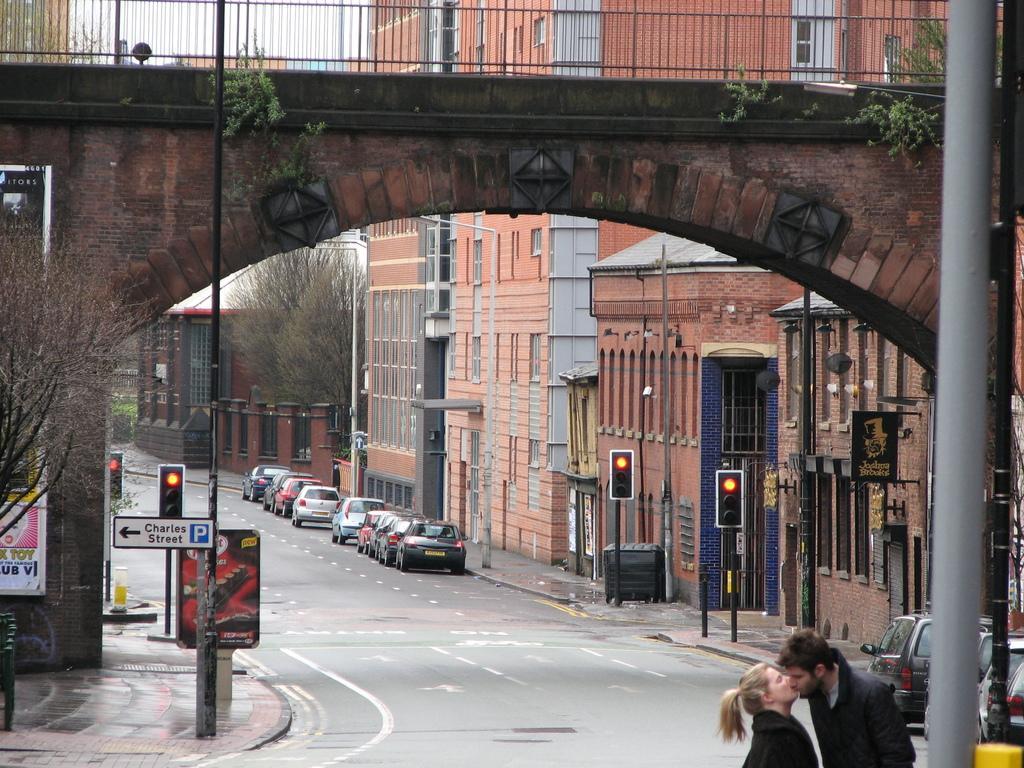Can you describe this image briefly? In this picture we can see a man and a woman kissing each other. There is a pole and traffic signals on the poles on the right side. We can see a few vehicles on the road. There is a direction board, traffic signals and posters are visible on a wall on the left side. We can see an arch on a wall. There is a bridge on top of the image. We can see a few trees and buildings in the background. 